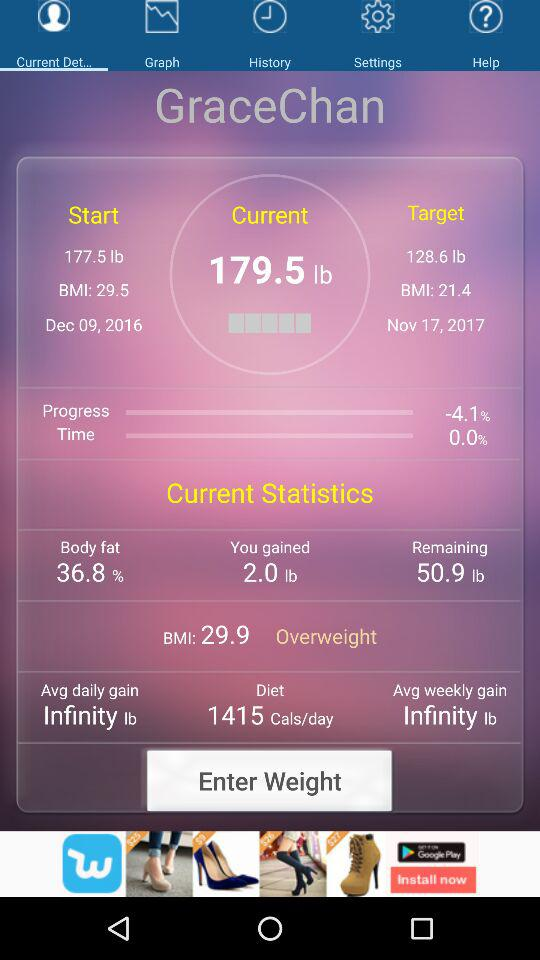What is the user name? The user name is Grace Chan. 